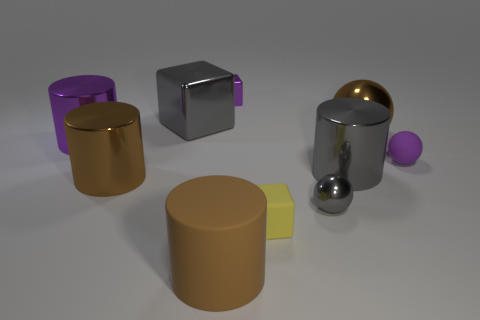The purple shiny object that is the same shape as the yellow matte object is what size?
Your answer should be compact. Small. Are there more cylinders than cubes?
Your response must be concise. Yes. Is the tiny purple matte thing the same shape as the small purple shiny thing?
Keep it short and to the point. No. There is a tiny thing that is behind the cube that is left of the tiny purple metal thing; what is it made of?
Your answer should be compact. Metal. There is a cube that is the same color as the tiny matte ball; what material is it?
Provide a succinct answer. Metal. Does the yellow rubber thing have the same size as the gray ball?
Your answer should be very brief. Yes. Are there any metal balls right of the large gray object on the right side of the small metallic block?
Ensure brevity in your answer.  Yes. What size is the metal sphere that is the same color as the matte cylinder?
Keep it short and to the point. Large. The small metal object that is on the left side of the yellow rubber block has what shape?
Your answer should be compact. Cube. There is a brown metallic object in front of the brown thing that is behind the purple rubber sphere; how many brown metal things are in front of it?
Offer a terse response. 0. 